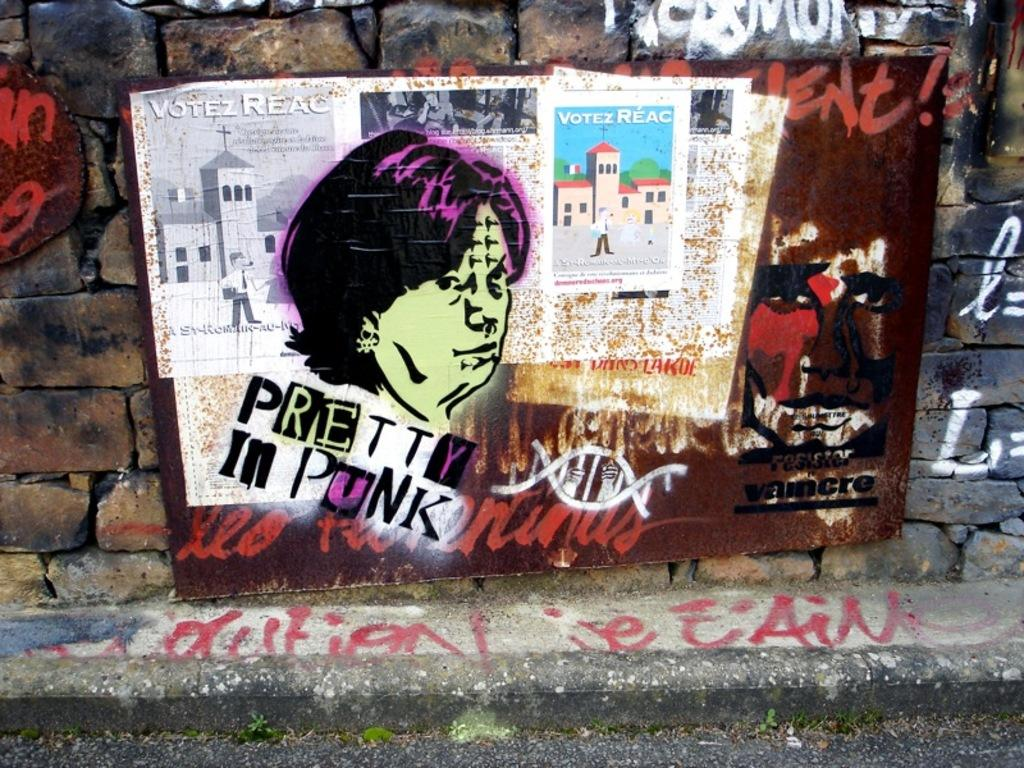<image>
Present a compact description of the photo's key features. Graffiti pictures and the words "pretty in punk" on an outside wall. 